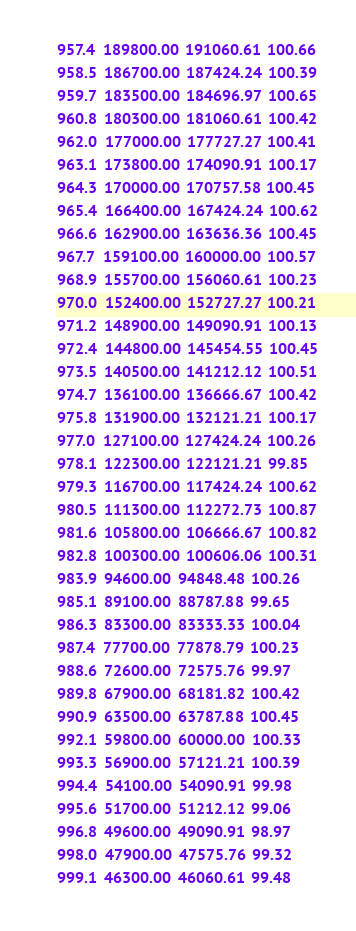Convert code to text. <code><loc_0><loc_0><loc_500><loc_500><_SML_>957.4  189800.00  191060.61  100.66
958.5  186700.00  187424.24  100.39
959.7  183500.00  184696.97  100.65
960.8  180300.00  181060.61  100.42
962.0  177000.00  177727.27  100.41
963.1  173800.00  174090.91  100.17
964.3  170000.00  170757.58  100.45
965.4  166400.00  167424.24  100.62
966.6  162900.00  163636.36  100.45
967.7  159100.00  160000.00  100.57
968.9  155700.00  156060.61  100.23
970.0  152400.00  152727.27  100.21
971.2  148900.00  149090.91  100.13
972.4  144800.00  145454.55  100.45
973.5  140500.00  141212.12  100.51
974.7  136100.00  136666.67  100.42
975.8  131900.00  132121.21  100.17
977.0  127100.00  127424.24  100.26
978.1  122300.00  122121.21  99.85
979.3  116700.00  117424.24  100.62
980.5  111300.00  112272.73  100.87
981.6  105800.00  106666.67  100.82
982.8  100300.00  100606.06  100.31
983.9  94600.00  94848.48  100.26
985.1  89100.00  88787.88  99.65
986.3  83300.00  83333.33  100.04
987.4  77700.00  77878.79  100.23
988.6  72600.00  72575.76  99.97
989.8  67900.00  68181.82  100.42
990.9  63500.00  63787.88  100.45
992.1  59800.00  60000.00  100.33
993.3  56900.00  57121.21  100.39
994.4  54100.00  54090.91  99.98
995.6  51700.00  51212.12  99.06
996.8  49600.00  49090.91  98.97
998.0  47900.00  47575.76  99.32
999.1  46300.00  46060.61  99.48</code> 